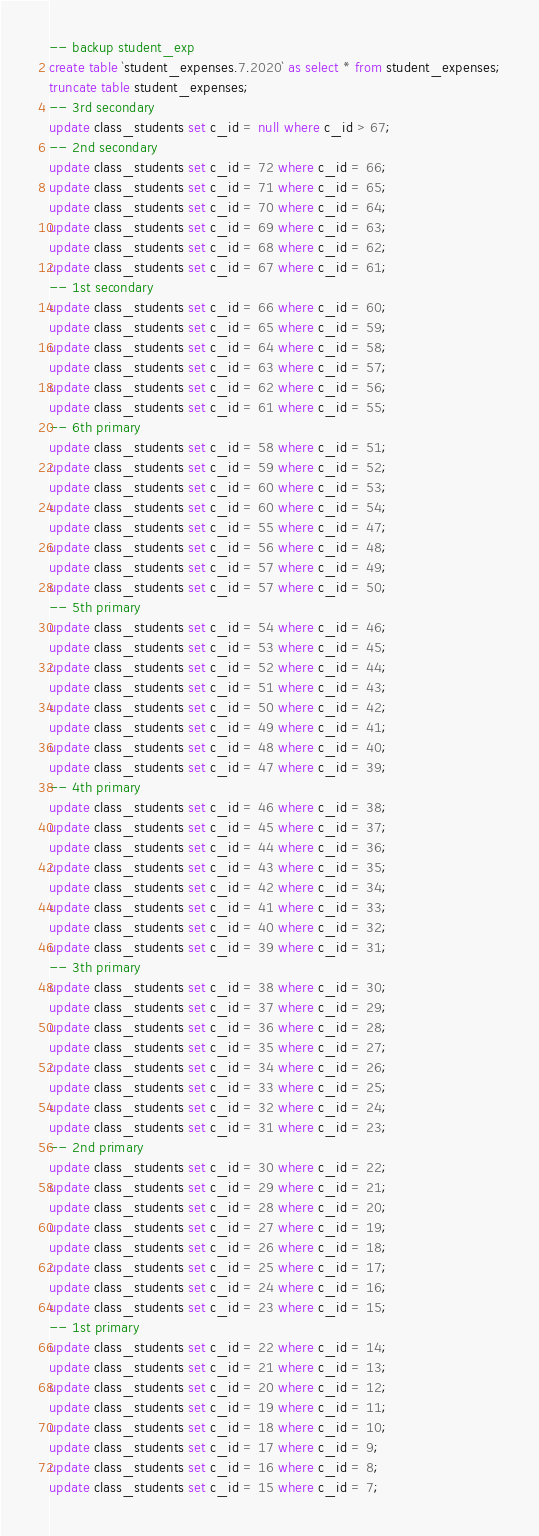Convert code to text. <code><loc_0><loc_0><loc_500><loc_500><_SQL_>-- backup student_exp
create table `student_expenses.7.2020` as select * from student_expenses;
truncate table student_expenses;
-- 3rd secondary
update class_students set c_id = null where c_id > 67;
-- 2nd secondary
update class_students set c_id = 72 where c_id = 66;
update class_students set c_id = 71 where c_id = 65;
update class_students set c_id = 70 where c_id = 64;
update class_students set c_id = 69 where c_id = 63;
update class_students set c_id = 68 where c_id = 62;
update class_students set c_id = 67 where c_id = 61;
-- 1st secondary
update class_students set c_id = 66 where c_id = 60;
update class_students set c_id = 65 where c_id = 59;
update class_students set c_id = 64 where c_id = 58;
update class_students set c_id = 63 where c_id = 57;
update class_students set c_id = 62 where c_id = 56;
update class_students set c_id = 61 where c_id = 55;
-- 6th primary
update class_students set c_id = 58 where c_id = 51;
update class_students set c_id = 59 where c_id = 52;
update class_students set c_id = 60 where c_id = 53;
update class_students set c_id = 60 where c_id = 54;
update class_students set c_id = 55 where c_id = 47;
update class_students set c_id = 56 where c_id = 48;
update class_students set c_id = 57 where c_id = 49;
update class_students set c_id = 57 where c_id = 50;
-- 5th primary
update class_students set c_id = 54 where c_id = 46;
update class_students set c_id = 53 where c_id = 45;
update class_students set c_id = 52 where c_id = 44;
update class_students set c_id = 51 where c_id = 43;
update class_students set c_id = 50 where c_id = 42;
update class_students set c_id = 49 where c_id = 41;
update class_students set c_id = 48 where c_id = 40;
update class_students set c_id = 47 where c_id = 39;
-- 4th primary
update class_students set c_id = 46 where c_id = 38;
update class_students set c_id = 45 where c_id = 37;
update class_students set c_id = 44 where c_id = 36;
update class_students set c_id = 43 where c_id = 35;
update class_students set c_id = 42 where c_id = 34;
update class_students set c_id = 41 where c_id = 33;
update class_students set c_id = 40 where c_id = 32;
update class_students set c_id = 39 where c_id = 31;
-- 3th primary
update class_students set c_id = 38 where c_id = 30;
update class_students set c_id = 37 where c_id = 29;
update class_students set c_id = 36 where c_id = 28;
update class_students set c_id = 35 where c_id = 27;
update class_students set c_id = 34 where c_id = 26;
update class_students set c_id = 33 where c_id = 25;
update class_students set c_id = 32 where c_id = 24;
update class_students set c_id = 31 where c_id = 23;
-- 2nd primary
update class_students set c_id = 30 where c_id = 22;
update class_students set c_id = 29 where c_id = 21;
update class_students set c_id = 28 where c_id = 20;
update class_students set c_id = 27 where c_id = 19;
update class_students set c_id = 26 where c_id = 18;
update class_students set c_id = 25 where c_id = 17;
update class_students set c_id = 24 where c_id = 16;
update class_students set c_id = 23 where c_id = 15;
-- 1st primary
update class_students set c_id = 22 where c_id = 14;
update class_students set c_id = 21 where c_id = 13;
update class_students set c_id = 20 where c_id = 12;
update class_students set c_id = 19 where c_id = 11;
update class_students set c_id = 18 where c_id = 10;
update class_students set c_id = 17 where c_id = 9;
update class_students set c_id = 16 where c_id = 8;
update class_students set c_id = 15 where c_id = 7;



</code> 